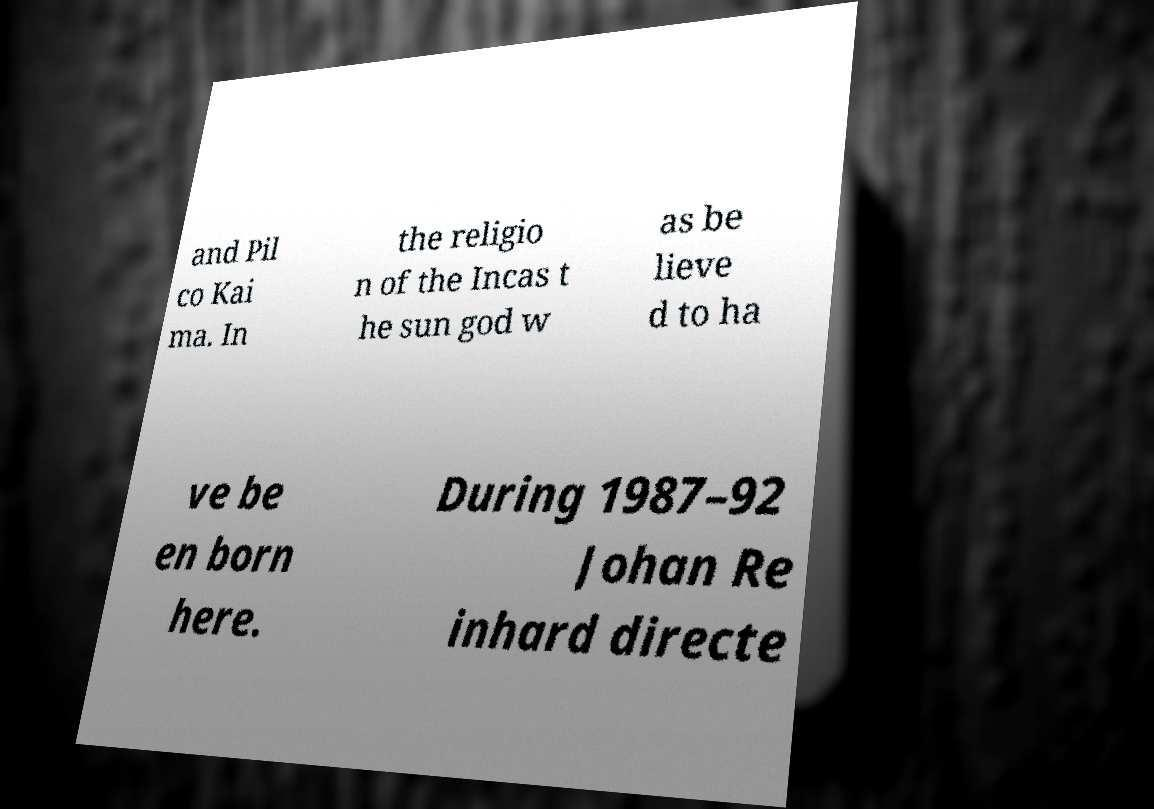Can you accurately transcribe the text from the provided image for me? and Pil co Kai ma. In the religio n of the Incas t he sun god w as be lieve d to ha ve be en born here. During 1987–92 Johan Re inhard directe 